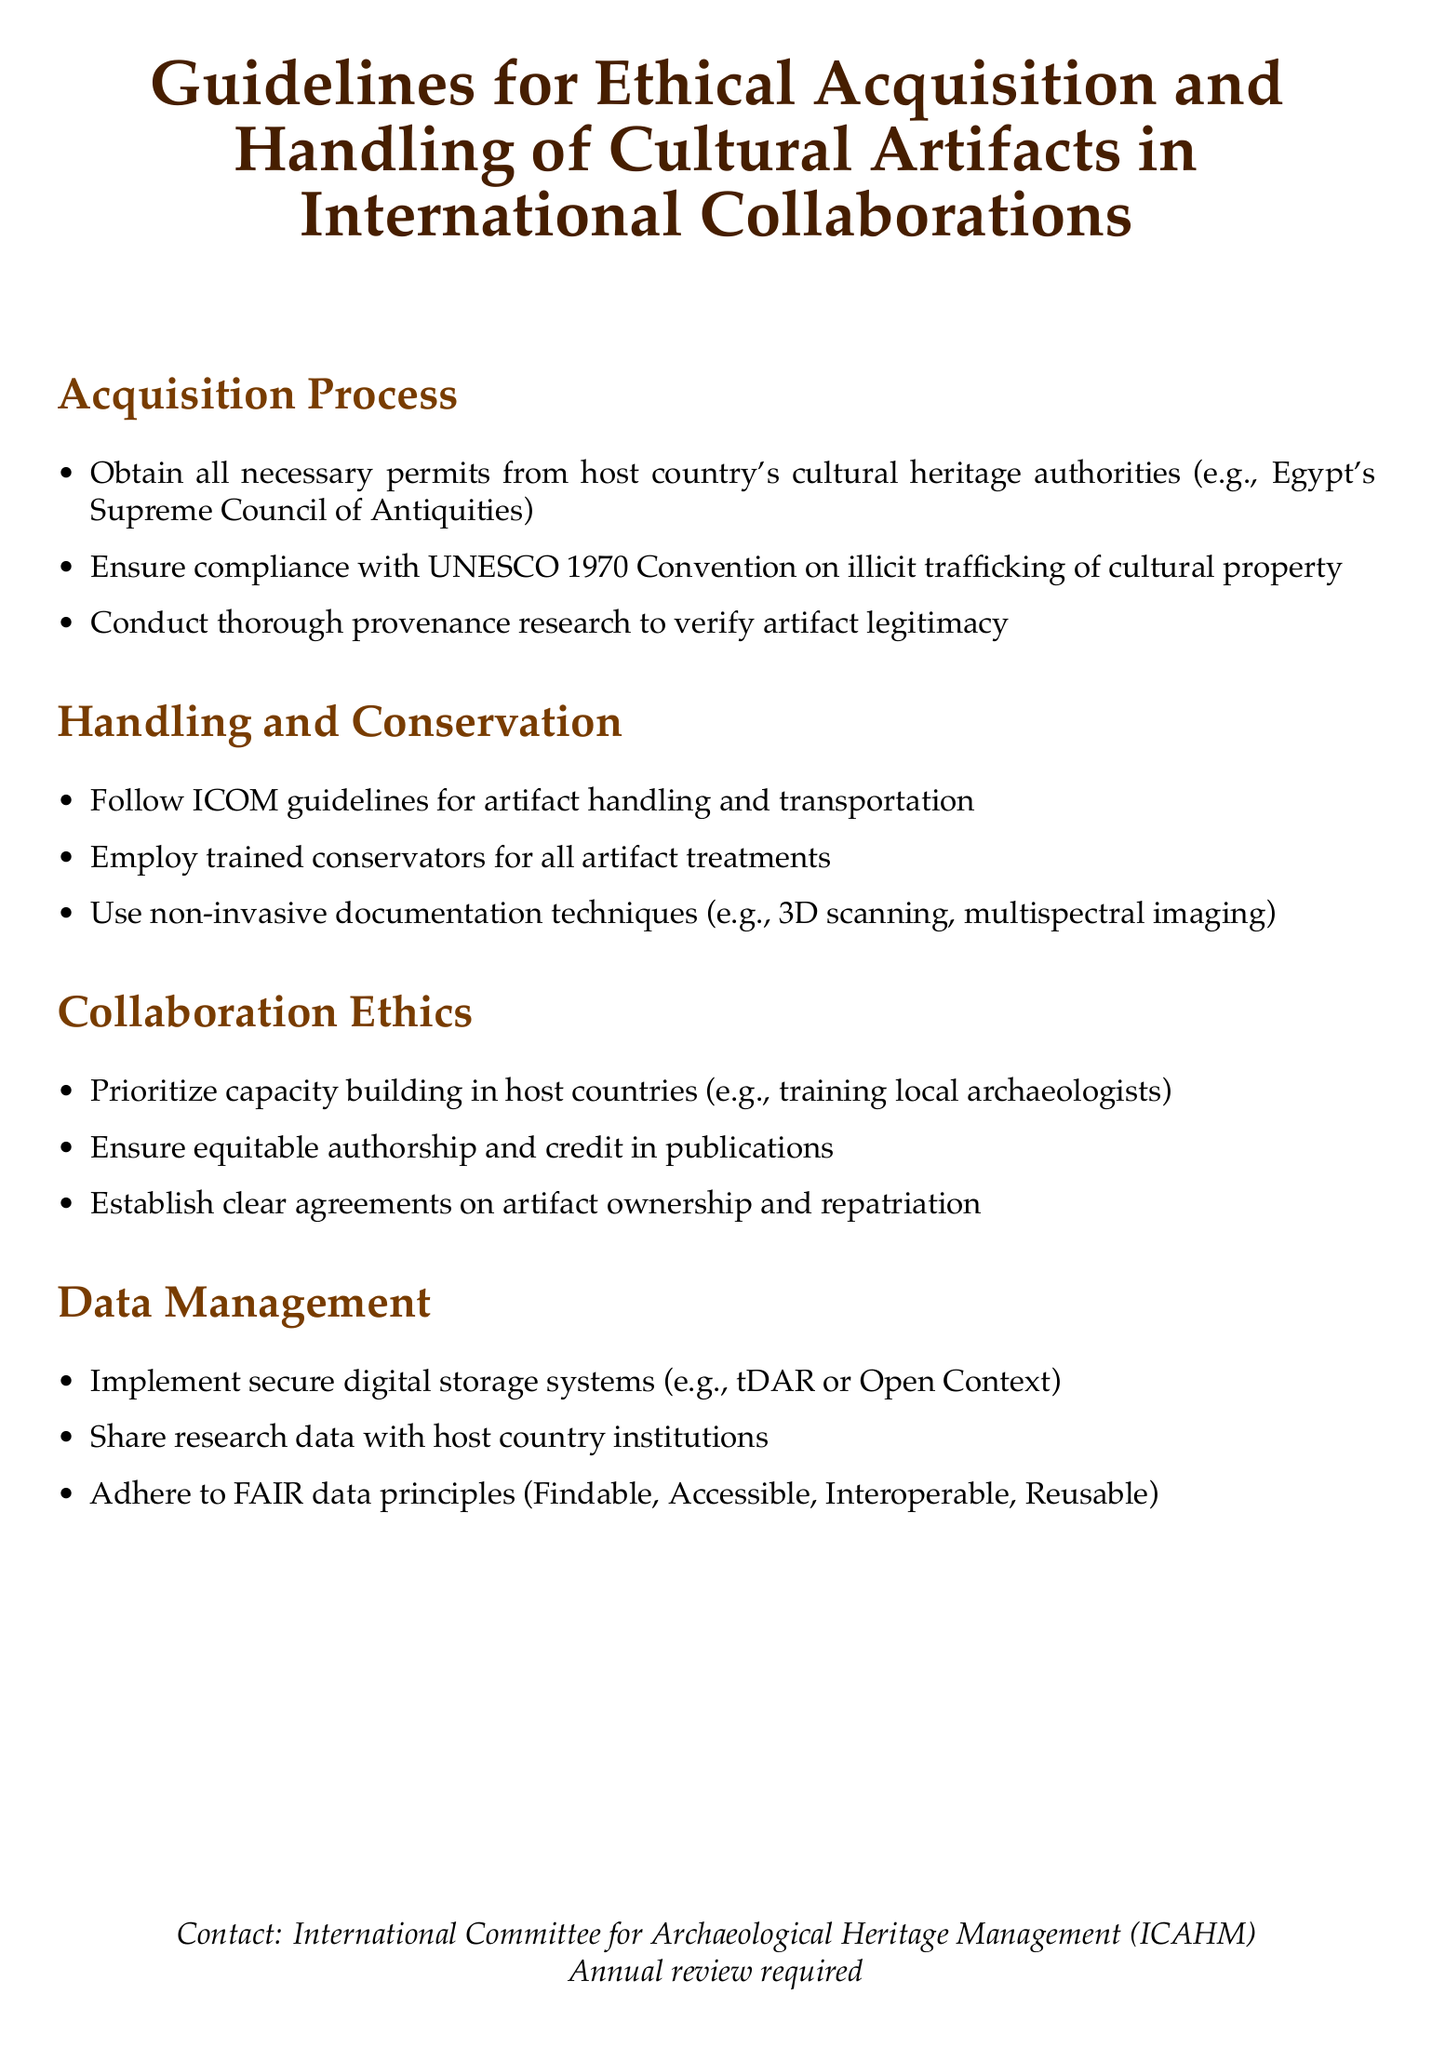What organization’s guidelines are referenced for artifact handling? The document mentions ICOM (International Council of Museums) for guidelines related to artifact handling.
Answer: ICOM Which convention must be complied with regarding illicit trafficking? The document states the compliance with UNESCO 1970 Convention on illicit trafficking of cultural property is necessary for acquisition.
Answer: UNESCO 1970 Convention What is the first step in the acquisition process? The document highlights obtaining necessary permits from host country's cultural heritage authorities as the first step in the acquisition process.
Answer: Obtain necessary permits What type of techniques should be used for documentation? According to the handling and conservation section, non-invasive techniques like 3D scanning and multispectral imaging should be employed.
Answer: Non-invasive techniques What principle should data management adhere to? The principles regarding data management are outlined as FAIR (Findable, Accessible, Interoperable, Reusable) principles that should be adhered to.
Answer: FAIR principles What should be prioritized in collaboration ethics? The document states that capacity building in host countries should be prioritized in collaboration ethics.
Answer: Capacity building How often is the review of the document required? The end of the document mentions that an annual review is required.
Answer: Annual review 